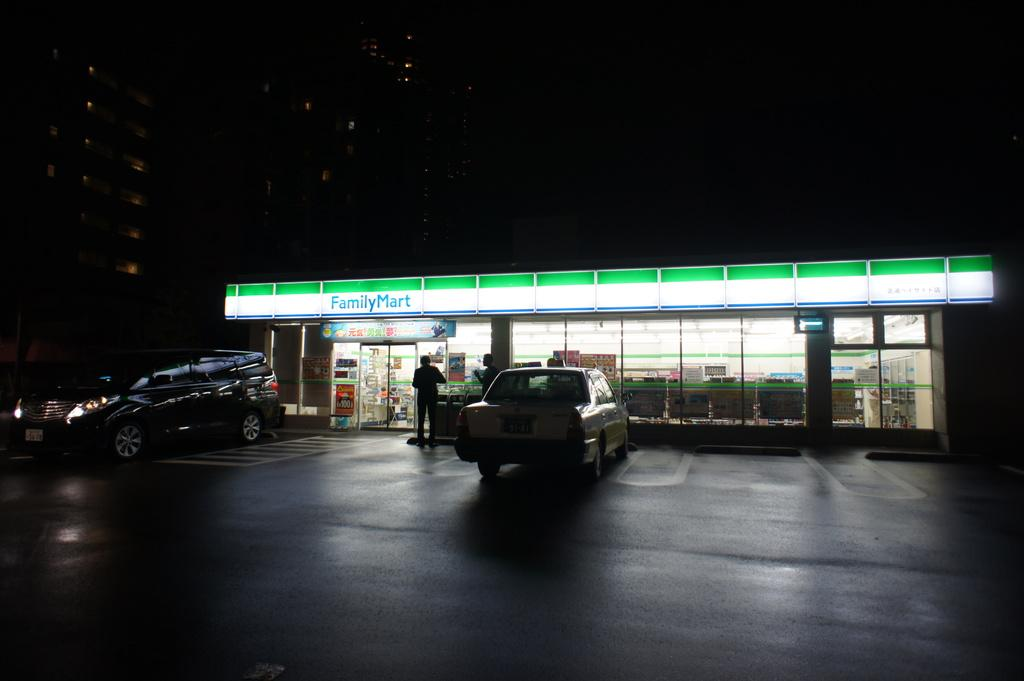Provide a one-sentence caption for the provided image. Two people are standing outside a Family Mart store. 